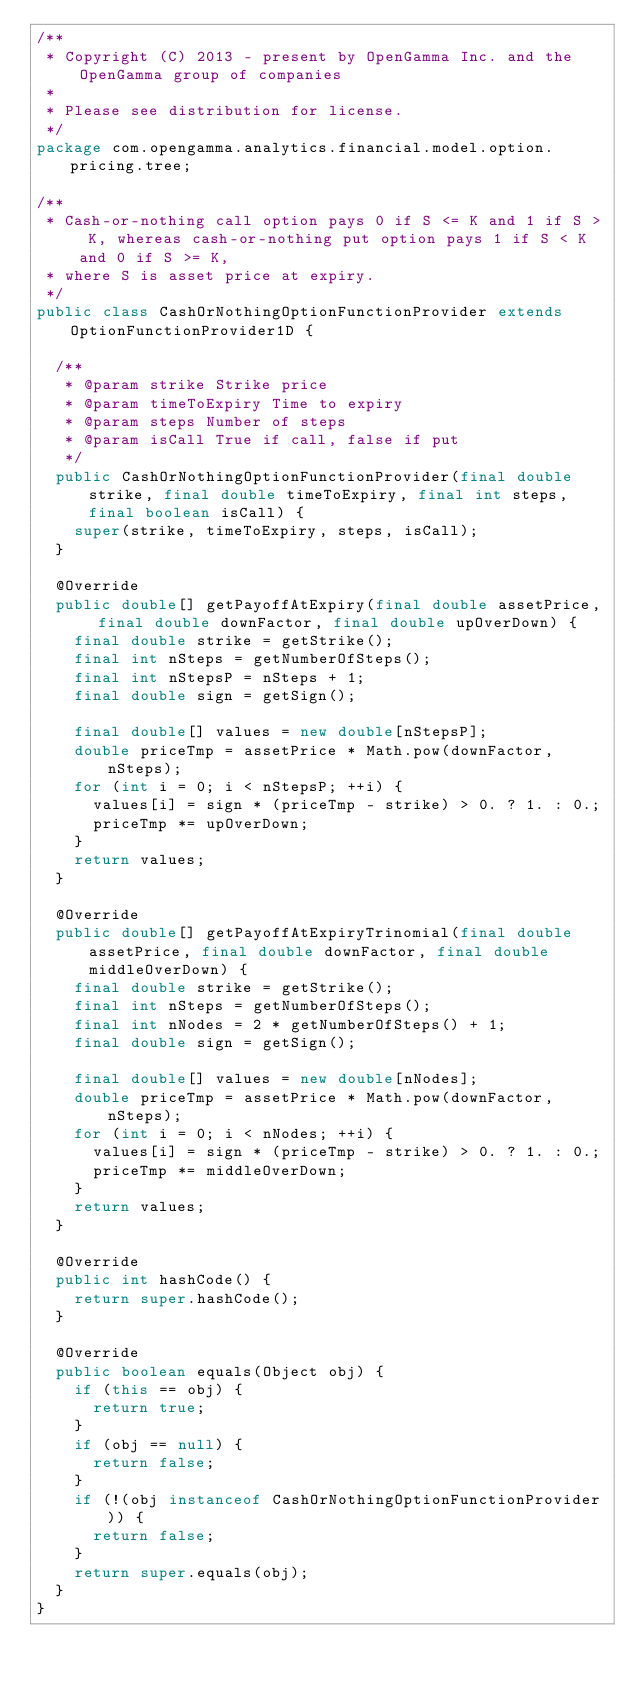Convert code to text. <code><loc_0><loc_0><loc_500><loc_500><_Java_>/**
 * Copyright (C) 2013 - present by OpenGamma Inc. and the OpenGamma group of companies
 * 
 * Please see distribution for license.
 */
package com.opengamma.analytics.financial.model.option.pricing.tree;

/**
 * Cash-or-nothing call option pays 0 if S <= K and 1 if S > K, whereas cash-or-nothing put option pays 1 if S < K and 0 if S >= K, 
 * where S is asset price at expiry.
 */
public class CashOrNothingOptionFunctionProvider extends OptionFunctionProvider1D {

  /**
   * @param strike Strike price
   * @param timeToExpiry Time to expiry
   * @param steps Number of steps
   * @param isCall True if call, false if put
   */
  public CashOrNothingOptionFunctionProvider(final double strike, final double timeToExpiry, final int steps, final boolean isCall) {
    super(strike, timeToExpiry, steps, isCall);
  }

  @Override
  public double[] getPayoffAtExpiry(final double assetPrice, final double downFactor, final double upOverDown) {
    final double strike = getStrike();
    final int nSteps = getNumberOfSteps();
    final int nStepsP = nSteps + 1;
    final double sign = getSign();

    final double[] values = new double[nStepsP];
    double priceTmp = assetPrice * Math.pow(downFactor, nSteps);
    for (int i = 0; i < nStepsP; ++i) {
      values[i] = sign * (priceTmp - strike) > 0. ? 1. : 0.;
      priceTmp *= upOverDown;
    }
    return values;
  }

  @Override
  public double[] getPayoffAtExpiryTrinomial(final double assetPrice, final double downFactor, final double middleOverDown) {
    final double strike = getStrike();
    final int nSteps = getNumberOfSteps();
    final int nNodes = 2 * getNumberOfSteps() + 1;
    final double sign = getSign();

    final double[] values = new double[nNodes];
    double priceTmp = assetPrice * Math.pow(downFactor, nSteps);
    for (int i = 0; i < nNodes; ++i) {
      values[i] = sign * (priceTmp - strike) > 0. ? 1. : 0.;
      priceTmp *= middleOverDown;
    }
    return values;
  }

  @Override
  public int hashCode() {
    return super.hashCode();
  }

  @Override
  public boolean equals(Object obj) {
    if (this == obj) {
      return true;
    }
    if (obj == null) {
      return false;
    }
    if (!(obj instanceof CashOrNothingOptionFunctionProvider)) {
      return false;
    }
    return super.equals(obj);
  }
}
</code> 